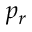<formula> <loc_0><loc_0><loc_500><loc_500>p _ { r }</formula> 